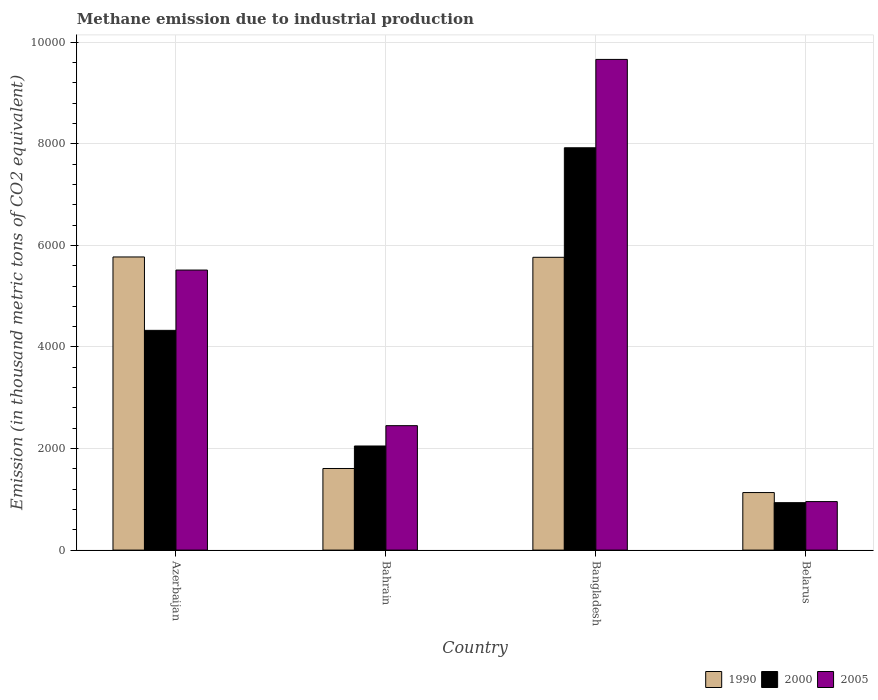How many groups of bars are there?
Provide a succinct answer. 4. Are the number of bars on each tick of the X-axis equal?
Make the answer very short. Yes. How many bars are there on the 4th tick from the left?
Make the answer very short. 3. How many bars are there on the 1st tick from the right?
Offer a very short reply. 3. In how many cases, is the number of bars for a given country not equal to the number of legend labels?
Provide a short and direct response. 0. What is the amount of methane emitted in 2000 in Bangladesh?
Offer a very short reply. 7923.4. Across all countries, what is the maximum amount of methane emitted in 2005?
Your response must be concise. 9663.6. Across all countries, what is the minimum amount of methane emitted in 2005?
Offer a very short reply. 955.3. In which country was the amount of methane emitted in 1990 minimum?
Keep it short and to the point. Belarus. What is the total amount of methane emitted in 2005 in the graph?
Keep it short and to the point. 1.86e+04. What is the difference between the amount of methane emitted in 2000 in Bahrain and that in Bangladesh?
Ensure brevity in your answer.  -5873.1. What is the difference between the amount of methane emitted in 2000 in Bahrain and the amount of methane emitted in 2005 in Azerbaijan?
Your answer should be very brief. -3464.9. What is the average amount of methane emitted in 1990 per country?
Your answer should be compact. 3569.95. What is the difference between the amount of methane emitted of/in 2005 and amount of methane emitted of/in 1990 in Azerbaijan?
Provide a short and direct response. -257.8. What is the ratio of the amount of methane emitted in 1990 in Bangladesh to that in Belarus?
Your answer should be compact. 5.09. Is the amount of methane emitted in 2005 in Azerbaijan less than that in Bangladesh?
Provide a succinct answer. Yes. Is the difference between the amount of methane emitted in 2005 in Bahrain and Bangladesh greater than the difference between the amount of methane emitted in 1990 in Bahrain and Bangladesh?
Give a very brief answer. No. What is the difference between the highest and the second highest amount of methane emitted in 2000?
Ensure brevity in your answer.  -5873.1. What is the difference between the highest and the lowest amount of methane emitted in 1990?
Your response must be concise. 4639.8. Is the sum of the amount of methane emitted in 2000 in Azerbaijan and Belarus greater than the maximum amount of methane emitted in 1990 across all countries?
Give a very brief answer. No. How many bars are there?
Ensure brevity in your answer.  12. Are all the bars in the graph horizontal?
Make the answer very short. No. What is the difference between two consecutive major ticks on the Y-axis?
Provide a short and direct response. 2000. Are the values on the major ticks of Y-axis written in scientific E-notation?
Your response must be concise. No. Does the graph contain any zero values?
Offer a terse response. No. Does the graph contain grids?
Give a very brief answer. Yes. Where does the legend appear in the graph?
Offer a terse response. Bottom right. How are the legend labels stacked?
Offer a very short reply. Horizontal. What is the title of the graph?
Your response must be concise. Methane emission due to industrial production. What is the label or title of the X-axis?
Your answer should be very brief. Country. What is the label or title of the Y-axis?
Provide a short and direct response. Emission (in thousand metric tons of CO2 equivalent). What is the Emission (in thousand metric tons of CO2 equivalent) of 1990 in Azerbaijan?
Offer a very short reply. 5773. What is the Emission (in thousand metric tons of CO2 equivalent) of 2000 in Azerbaijan?
Ensure brevity in your answer.  4327.8. What is the Emission (in thousand metric tons of CO2 equivalent) of 2005 in Azerbaijan?
Offer a very short reply. 5515.2. What is the Emission (in thousand metric tons of CO2 equivalent) in 1990 in Bahrain?
Your response must be concise. 1607.3. What is the Emission (in thousand metric tons of CO2 equivalent) in 2000 in Bahrain?
Make the answer very short. 2050.3. What is the Emission (in thousand metric tons of CO2 equivalent) in 2005 in Bahrain?
Provide a succinct answer. 2450.6. What is the Emission (in thousand metric tons of CO2 equivalent) in 1990 in Bangladesh?
Your answer should be compact. 5766.3. What is the Emission (in thousand metric tons of CO2 equivalent) of 2000 in Bangladesh?
Your answer should be very brief. 7923.4. What is the Emission (in thousand metric tons of CO2 equivalent) in 2005 in Bangladesh?
Ensure brevity in your answer.  9663.6. What is the Emission (in thousand metric tons of CO2 equivalent) in 1990 in Belarus?
Make the answer very short. 1133.2. What is the Emission (in thousand metric tons of CO2 equivalent) in 2000 in Belarus?
Your response must be concise. 934.2. What is the Emission (in thousand metric tons of CO2 equivalent) of 2005 in Belarus?
Your response must be concise. 955.3. Across all countries, what is the maximum Emission (in thousand metric tons of CO2 equivalent) of 1990?
Your answer should be compact. 5773. Across all countries, what is the maximum Emission (in thousand metric tons of CO2 equivalent) of 2000?
Your answer should be very brief. 7923.4. Across all countries, what is the maximum Emission (in thousand metric tons of CO2 equivalent) in 2005?
Make the answer very short. 9663.6. Across all countries, what is the minimum Emission (in thousand metric tons of CO2 equivalent) in 1990?
Offer a terse response. 1133.2. Across all countries, what is the minimum Emission (in thousand metric tons of CO2 equivalent) in 2000?
Your response must be concise. 934.2. Across all countries, what is the minimum Emission (in thousand metric tons of CO2 equivalent) of 2005?
Your response must be concise. 955.3. What is the total Emission (in thousand metric tons of CO2 equivalent) of 1990 in the graph?
Ensure brevity in your answer.  1.43e+04. What is the total Emission (in thousand metric tons of CO2 equivalent) in 2000 in the graph?
Offer a terse response. 1.52e+04. What is the total Emission (in thousand metric tons of CO2 equivalent) in 2005 in the graph?
Provide a short and direct response. 1.86e+04. What is the difference between the Emission (in thousand metric tons of CO2 equivalent) of 1990 in Azerbaijan and that in Bahrain?
Offer a very short reply. 4165.7. What is the difference between the Emission (in thousand metric tons of CO2 equivalent) of 2000 in Azerbaijan and that in Bahrain?
Make the answer very short. 2277.5. What is the difference between the Emission (in thousand metric tons of CO2 equivalent) of 2005 in Azerbaijan and that in Bahrain?
Ensure brevity in your answer.  3064.6. What is the difference between the Emission (in thousand metric tons of CO2 equivalent) in 2000 in Azerbaijan and that in Bangladesh?
Ensure brevity in your answer.  -3595.6. What is the difference between the Emission (in thousand metric tons of CO2 equivalent) in 2005 in Azerbaijan and that in Bangladesh?
Your answer should be compact. -4148.4. What is the difference between the Emission (in thousand metric tons of CO2 equivalent) of 1990 in Azerbaijan and that in Belarus?
Give a very brief answer. 4639.8. What is the difference between the Emission (in thousand metric tons of CO2 equivalent) of 2000 in Azerbaijan and that in Belarus?
Offer a very short reply. 3393.6. What is the difference between the Emission (in thousand metric tons of CO2 equivalent) of 2005 in Azerbaijan and that in Belarus?
Offer a terse response. 4559.9. What is the difference between the Emission (in thousand metric tons of CO2 equivalent) of 1990 in Bahrain and that in Bangladesh?
Give a very brief answer. -4159. What is the difference between the Emission (in thousand metric tons of CO2 equivalent) in 2000 in Bahrain and that in Bangladesh?
Make the answer very short. -5873.1. What is the difference between the Emission (in thousand metric tons of CO2 equivalent) in 2005 in Bahrain and that in Bangladesh?
Offer a terse response. -7213. What is the difference between the Emission (in thousand metric tons of CO2 equivalent) in 1990 in Bahrain and that in Belarus?
Offer a terse response. 474.1. What is the difference between the Emission (in thousand metric tons of CO2 equivalent) of 2000 in Bahrain and that in Belarus?
Your answer should be compact. 1116.1. What is the difference between the Emission (in thousand metric tons of CO2 equivalent) in 2005 in Bahrain and that in Belarus?
Provide a succinct answer. 1495.3. What is the difference between the Emission (in thousand metric tons of CO2 equivalent) in 1990 in Bangladesh and that in Belarus?
Make the answer very short. 4633.1. What is the difference between the Emission (in thousand metric tons of CO2 equivalent) in 2000 in Bangladesh and that in Belarus?
Your answer should be very brief. 6989.2. What is the difference between the Emission (in thousand metric tons of CO2 equivalent) in 2005 in Bangladesh and that in Belarus?
Offer a very short reply. 8708.3. What is the difference between the Emission (in thousand metric tons of CO2 equivalent) in 1990 in Azerbaijan and the Emission (in thousand metric tons of CO2 equivalent) in 2000 in Bahrain?
Offer a very short reply. 3722.7. What is the difference between the Emission (in thousand metric tons of CO2 equivalent) in 1990 in Azerbaijan and the Emission (in thousand metric tons of CO2 equivalent) in 2005 in Bahrain?
Ensure brevity in your answer.  3322.4. What is the difference between the Emission (in thousand metric tons of CO2 equivalent) of 2000 in Azerbaijan and the Emission (in thousand metric tons of CO2 equivalent) of 2005 in Bahrain?
Your answer should be very brief. 1877.2. What is the difference between the Emission (in thousand metric tons of CO2 equivalent) of 1990 in Azerbaijan and the Emission (in thousand metric tons of CO2 equivalent) of 2000 in Bangladesh?
Give a very brief answer. -2150.4. What is the difference between the Emission (in thousand metric tons of CO2 equivalent) in 1990 in Azerbaijan and the Emission (in thousand metric tons of CO2 equivalent) in 2005 in Bangladesh?
Ensure brevity in your answer.  -3890.6. What is the difference between the Emission (in thousand metric tons of CO2 equivalent) of 2000 in Azerbaijan and the Emission (in thousand metric tons of CO2 equivalent) of 2005 in Bangladesh?
Offer a very short reply. -5335.8. What is the difference between the Emission (in thousand metric tons of CO2 equivalent) in 1990 in Azerbaijan and the Emission (in thousand metric tons of CO2 equivalent) in 2000 in Belarus?
Your answer should be very brief. 4838.8. What is the difference between the Emission (in thousand metric tons of CO2 equivalent) in 1990 in Azerbaijan and the Emission (in thousand metric tons of CO2 equivalent) in 2005 in Belarus?
Give a very brief answer. 4817.7. What is the difference between the Emission (in thousand metric tons of CO2 equivalent) of 2000 in Azerbaijan and the Emission (in thousand metric tons of CO2 equivalent) of 2005 in Belarus?
Your answer should be very brief. 3372.5. What is the difference between the Emission (in thousand metric tons of CO2 equivalent) of 1990 in Bahrain and the Emission (in thousand metric tons of CO2 equivalent) of 2000 in Bangladesh?
Provide a short and direct response. -6316.1. What is the difference between the Emission (in thousand metric tons of CO2 equivalent) of 1990 in Bahrain and the Emission (in thousand metric tons of CO2 equivalent) of 2005 in Bangladesh?
Give a very brief answer. -8056.3. What is the difference between the Emission (in thousand metric tons of CO2 equivalent) in 2000 in Bahrain and the Emission (in thousand metric tons of CO2 equivalent) in 2005 in Bangladesh?
Keep it short and to the point. -7613.3. What is the difference between the Emission (in thousand metric tons of CO2 equivalent) of 1990 in Bahrain and the Emission (in thousand metric tons of CO2 equivalent) of 2000 in Belarus?
Your answer should be compact. 673.1. What is the difference between the Emission (in thousand metric tons of CO2 equivalent) in 1990 in Bahrain and the Emission (in thousand metric tons of CO2 equivalent) in 2005 in Belarus?
Your response must be concise. 652. What is the difference between the Emission (in thousand metric tons of CO2 equivalent) of 2000 in Bahrain and the Emission (in thousand metric tons of CO2 equivalent) of 2005 in Belarus?
Offer a very short reply. 1095. What is the difference between the Emission (in thousand metric tons of CO2 equivalent) in 1990 in Bangladesh and the Emission (in thousand metric tons of CO2 equivalent) in 2000 in Belarus?
Offer a terse response. 4832.1. What is the difference between the Emission (in thousand metric tons of CO2 equivalent) in 1990 in Bangladesh and the Emission (in thousand metric tons of CO2 equivalent) in 2005 in Belarus?
Provide a short and direct response. 4811. What is the difference between the Emission (in thousand metric tons of CO2 equivalent) in 2000 in Bangladesh and the Emission (in thousand metric tons of CO2 equivalent) in 2005 in Belarus?
Offer a very short reply. 6968.1. What is the average Emission (in thousand metric tons of CO2 equivalent) in 1990 per country?
Your answer should be compact. 3569.95. What is the average Emission (in thousand metric tons of CO2 equivalent) of 2000 per country?
Provide a short and direct response. 3808.93. What is the average Emission (in thousand metric tons of CO2 equivalent) in 2005 per country?
Provide a short and direct response. 4646.18. What is the difference between the Emission (in thousand metric tons of CO2 equivalent) of 1990 and Emission (in thousand metric tons of CO2 equivalent) of 2000 in Azerbaijan?
Offer a very short reply. 1445.2. What is the difference between the Emission (in thousand metric tons of CO2 equivalent) in 1990 and Emission (in thousand metric tons of CO2 equivalent) in 2005 in Azerbaijan?
Offer a terse response. 257.8. What is the difference between the Emission (in thousand metric tons of CO2 equivalent) of 2000 and Emission (in thousand metric tons of CO2 equivalent) of 2005 in Azerbaijan?
Offer a terse response. -1187.4. What is the difference between the Emission (in thousand metric tons of CO2 equivalent) of 1990 and Emission (in thousand metric tons of CO2 equivalent) of 2000 in Bahrain?
Your answer should be compact. -443. What is the difference between the Emission (in thousand metric tons of CO2 equivalent) in 1990 and Emission (in thousand metric tons of CO2 equivalent) in 2005 in Bahrain?
Offer a very short reply. -843.3. What is the difference between the Emission (in thousand metric tons of CO2 equivalent) in 2000 and Emission (in thousand metric tons of CO2 equivalent) in 2005 in Bahrain?
Ensure brevity in your answer.  -400.3. What is the difference between the Emission (in thousand metric tons of CO2 equivalent) of 1990 and Emission (in thousand metric tons of CO2 equivalent) of 2000 in Bangladesh?
Keep it short and to the point. -2157.1. What is the difference between the Emission (in thousand metric tons of CO2 equivalent) in 1990 and Emission (in thousand metric tons of CO2 equivalent) in 2005 in Bangladesh?
Make the answer very short. -3897.3. What is the difference between the Emission (in thousand metric tons of CO2 equivalent) of 2000 and Emission (in thousand metric tons of CO2 equivalent) of 2005 in Bangladesh?
Give a very brief answer. -1740.2. What is the difference between the Emission (in thousand metric tons of CO2 equivalent) in 1990 and Emission (in thousand metric tons of CO2 equivalent) in 2000 in Belarus?
Your response must be concise. 199. What is the difference between the Emission (in thousand metric tons of CO2 equivalent) in 1990 and Emission (in thousand metric tons of CO2 equivalent) in 2005 in Belarus?
Provide a succinct answer. 177.9. What is the difference between the Emission (in thousand metric tons of CO2 equivalent) in 2000 and Emission (in thousand metric tons of CO2 equivalent) in 2005 in Belarus?
Your response must be concise. -21.1. What is the ratio of the Emission (in thousand metric tons of CO2 equivalent) in 1990 in Azerbaijan to that in Bahrain?
Provide a short and direct response. 3.59. What is the ratio of the Emission (in thousand metric tons of CO2 equivalent) of 2000 in Azerbaijan to that in Bahrain?
Give a very brief answer. 2.11. What is the ratio of the Emission (in thousand metric tons of CO2 equivalent) of 2005 in Azerbaijan to that in Bahrain?
Your answer should be compact. 2.25. What is the ratio of the Emission (in thousand metric tons of CO2 equivalent) in 2000 in Azerbaijan to that in Bangladesh?
Offer a very short reply. 0.55. What is the ratio of the Emission (in thousand metric tons of CO2 equivalent) in 2005 in Azerbaijan to that in Bangladesh?
Ensure brevity in your answer.  0.57. What is the ratio of the Emission (in thousand metric tons of CO2 equivalent) of 1990 in Azerbaijan to that in Belarus?
Offer a terse response. 5.09. What is the ratio of the Emission (in thousand metric tons of CO2 equivalent) of 2000 in Azerbaijan to that in Belarus?
Make the answer very short. 4.63. What is the ratio of the Emission (in thousand metric tons of CO2 equivalent) of 2005 in Azerbaijan to that in Belarus?
Provide a succinct answer. 5.77. What is the ratio of the Emission (in thousand metric tons of CO2 equivalent) in 1990 in Bahrain to that in Bangladesh?
Your response must be concise. 0.28. What is the ratio of the Emission (in thousand metric tons of CO2 equivalent) of 2000 in Bahrain to that in Bangladesh?
Offer a terse response. 0.26. What is the ratio of the Emission (in thousand metric tons of CO2 equivalent) of 2005 in Bahrain to that in Bangladesh?
Provide a succinct answer. 0.25. What is the ratio of the Emission (in thousand metric tons of CO2 equivalent) of 1990 in Bahrain to that in Belarus?
Offer a terse response. 1.42. What is the ratio of the Emission (in thousand metric tons of CO2 equivalent) in 2000 in Bahrain to that in Belarus?
Make the answer very short. 2.19. What is the ratio of the Emission (in thousand metric tons of CO2 equivalent) in 2005 in Bahrain to that in Belarus?
Give a very brief answer. 2.57. What is the ratio of the Emission (in thousand metric tons of CO2 equivalent) in 1990 in Bangladesh to that in Belarus?
Ensure brevity in your answer.  5.09. What is the ratio of the Emission (in thousand metric tons of CO2 equivalent) in 2000 in Bangladesh to that in Belarus?
Your response must be concise. 8.48. What is the ratio of the Emission (in thousand metric tons of CO2 equivalent) in 2005 in Bangladesh to that in Belarus?
Ensure brevity in your answer.  10.12. What is the difference between the highest and the second highest Emission (in thousand metric tons of CO2 equivalent) in 1990?
Your response must be concise. 6.7. What is the difference between the highest and the second highest Emission (in thousand metric tons of CO2 equivalent) in 2000?
Give a very brief answer. 3595.6. What is the difference between the highest and the second highest Emission (in thousand metric tons of CO2 equivalent) in 2005?
Make the answer very short. 4148.4. What is the difference between the highest and the lowest Emission (in thousand metric tons of CO2 equivalent) of 1990?
Your response must be concise. 4639.8. What is the difference between the highest and the lowest Emission (in thousand metric tons of CO2 equivalent) of 2000?
Your answer should be compact. 6989.2. What is the difference between the highest and the lowest Emission (in thousand metric tons of CO2 equivalent) of 2005?
Your answer should be compact. 8708.3. 